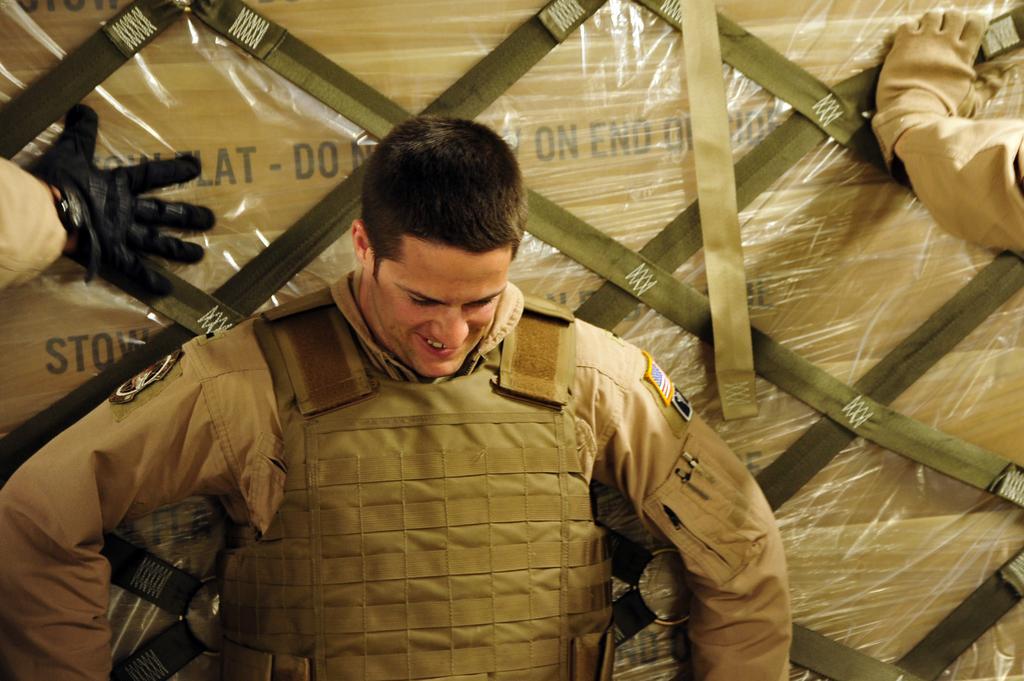Could you give a brief overview of what you see in this image? In front of the image there is an army personnel officer with a smile on his face, behind him there are hands of two other officers on a consignment packed in cover. 